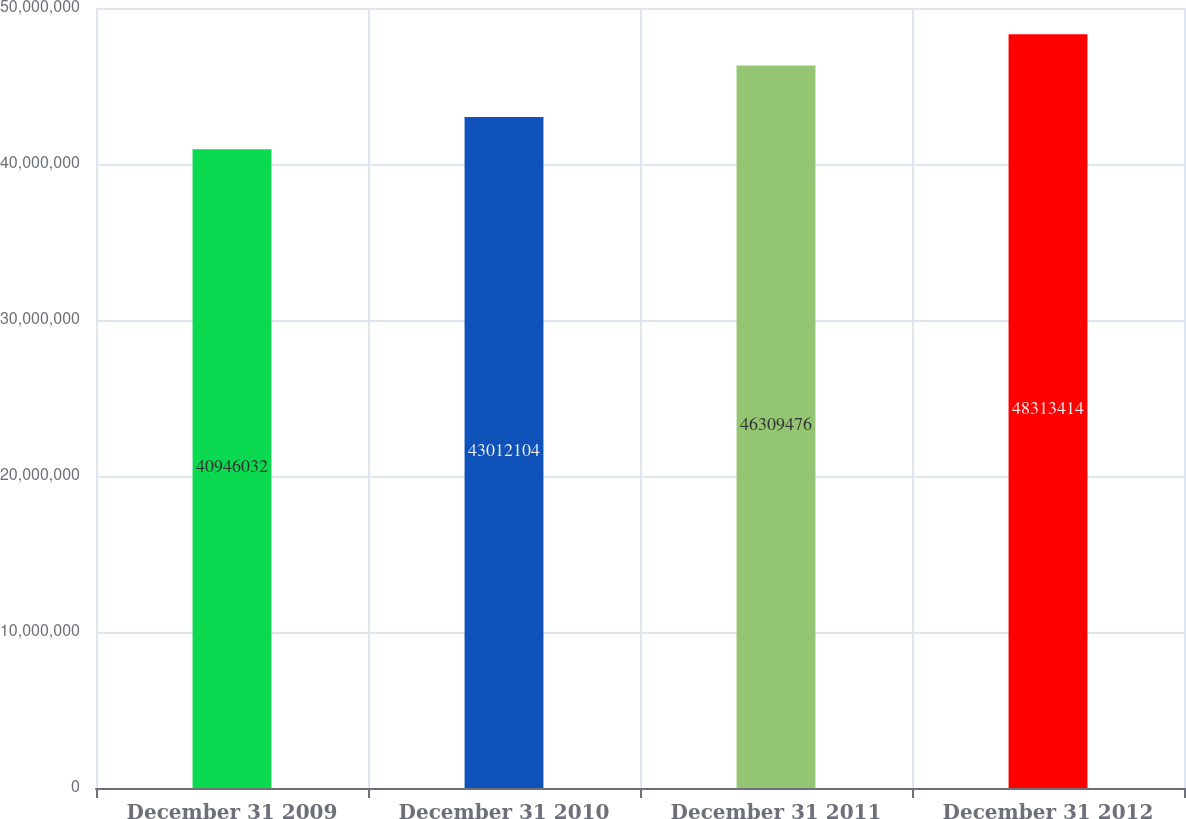<chart> <loc_0><loc_0><loc_500><loc_500><bar_chart><fcel>December 31 2009<fcel>December 31 2010<fcel>December 31 2011<fcel>December 31 2012<nl><fcel>4.0946e+07<fcel>4.30121e+07<fcel>4.63095e+07<fcel>4.83134e+07<nl></chart> 